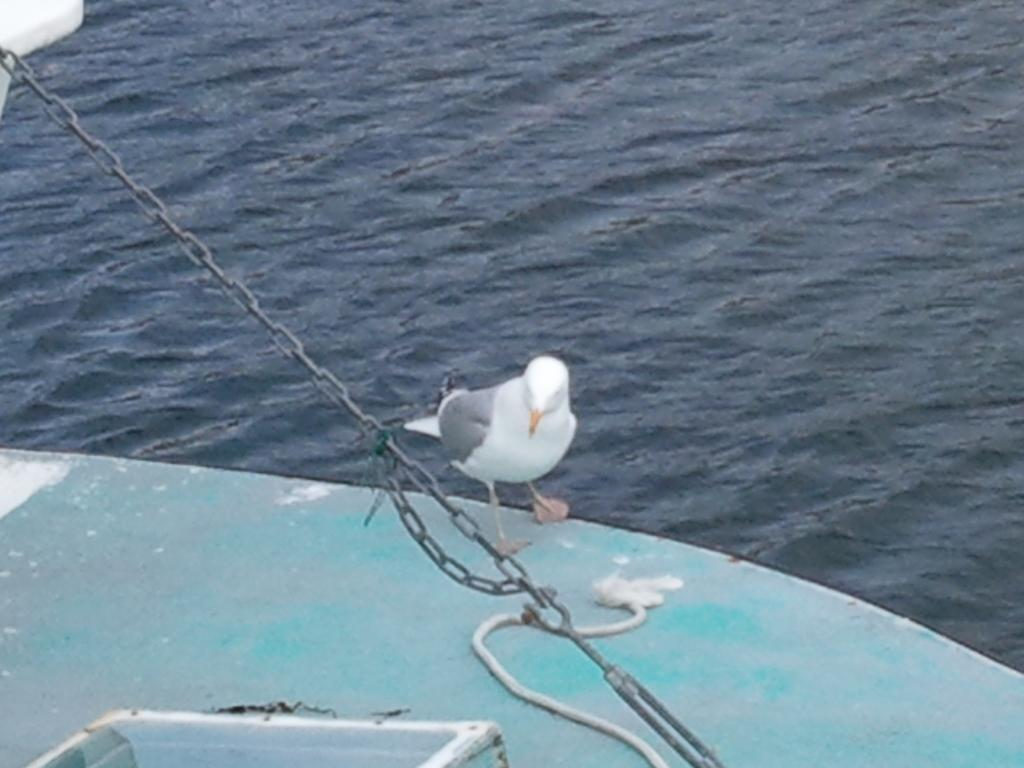What is the primary element in the image? There is water in the image. What can be found at the bottom of the image? There is an object and a rope at the bottom of the image. What type of animal is present in the image? There is a bird in the image. What type of material is the chain in the image made of? There is a metal chain in the image. What type of clouds can be seen in the downtown area of the image? There are no clouds or downtown area mentioned in the image; it primarily features water and objects at the bottom. 